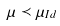<formula> <loc_0><loc_0><loc_500><loc_500>\mu \prec \mu _ { I d }</formula> 